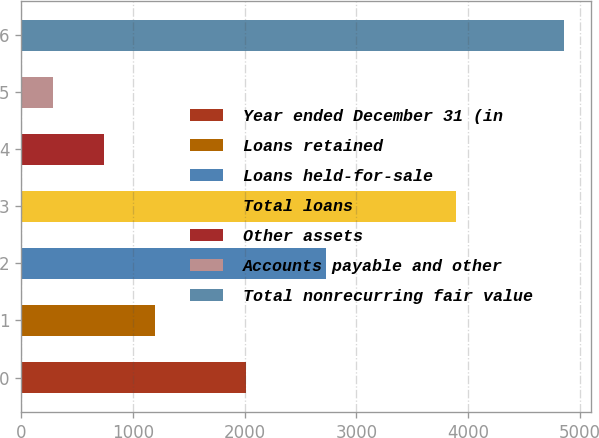Convert chart to OTSL. <chart><loc_0><loc_0><loc_500><loc_500><bar_chart><fcel>Year ended December 31 (in<fcel>Loans retained<fcel>Loans held-for-sale<fcel>Total loans<fcel>Other assets<fcel>Accounts payable and other<fcel>Total nonrecurring fair value<nl><fcel>2008<fcel>1199.4<fcel>2728<fcel>3887<fcel>742.2<fcel>285<fcel>4857<nl></chart> 